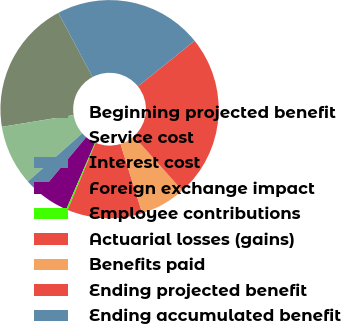<chart> <loc_0><loc_0><loc_500><loc_500><pie_chart><fcel>Beginning projected benefit<fcel>Service cost<fcel>Interest cost<fcel>Foreign exchange impact<fcel>Employee contributions<fcel>Actuarial losses (gains)<fcel>Benefits paid<fcel>Ending projected benefit<fcel>Ending accumulated benefit<nl><fcel>19.81%<fcel>8.94%<fcel>2.4%<fcel>4.58%<fcel>0.22%<fcel>11.12%<fcel>6.76%<fcel>24.17%<fcel>21.99%<nl></chart> 